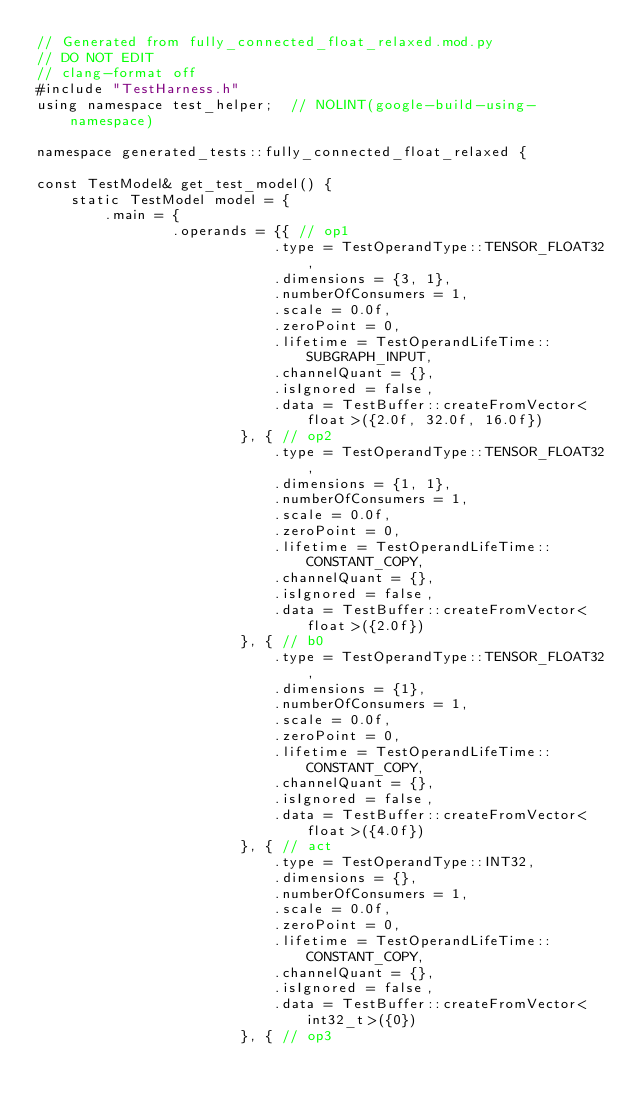<code> <loc_0><loc_0><loc_500><loc_500><_C++_>// Generated from fully_connected_float_relaxed.mod.py
// DO NOT EDIT
// clang-format off
#include "TestHarness.h"
using namespace test_helper;  // NOLINT(google-build-using-namespace)

namespace generated_tests::fully_connected_float_relaxed {

const TestModel& get_test_model() {
    static TestModel model = {
        .main = {
                .operands = {{ // op1
                            .type = TestOperandType::TENSOR_FLOAT32,
                            .dimensions = {3, 1},
                            .numberOfConsumers = 1,
                            .scale = 0.0f,
                            .zeroPoint = 0,
                            .lifetime = TestOperandLifeTime::SUBGRAPH_INPUT,
                            .channelQuant = {},
                            .isIgnored = false,
                            .data = TestBuffer::createFromVector<float>({2.0f, 32.0f, 16.0f})
                        }, { // op2
                            .type = TestOperandType::TENSOR_FLOAT32,
                            .dimensions = {1, 1},
                            .numberOfConsumers = 1,
                            .scale = 0.0f,
                            .zeroPoint = 0,
                            .lifetime = TestOperandLifeTime::CONSTANT_COPY,
                            .channelQuant = {},
                            .isIgnored = false,
                            .data = TestBuffer::createFromVector<float>({2.0f})
                        }, { // b0
                            .type = TestOperandType::TENSOR_FLOAT32,
                            .dimensions = {1},
                            .numberOfConsumers = 1,
                            .scale = 0.0f,
                            .zeroPoint = 0,
                            .lifetime = TestOperandLifeTime::CONSTANT_COPY,
                            .channelQuant = {},
                            .isIgnored = false,
                            .data = TestBuffer::createFromVector<float>({4.0f})
                        }, { // act
                            .type = TestOperandType::INT32,
                            .dimensions = {},
                            .numberOfConsumers = 1,
                            .scale = 0.0f,
                            .zeroPoint = 0,
                            .lifetime = TestOperandLifeTime::CONSTANT_COPY,
                            .channelQuant = {},
                            .isIgnored = false,
                            .data = TestBuffer::createFromVector<int32_t>({0})
                        }, { // op3</code> 